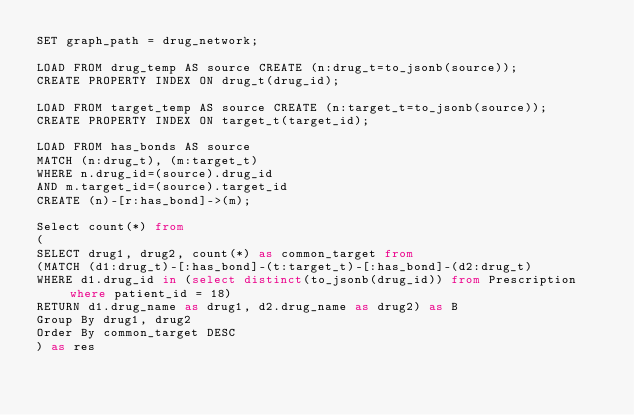Convert code to text. <code><loc_0><loc_0><loc_500><loc_500><_SQL_>SET graph_path = drug_network;

LOAD FROM drug_temp AS source CREATE (n:drug_t=to_jsonb(source));
CREATE PROPERTY INDEX ON drug_t(drug_id);

LOAD FROM target_temp AS source CREATE (n:target_t=to_jsonb(source));
CREATE PROPERTY INDEX ON target_t(target_id);

LOAD FROM has_bonds AS source
MATCH (n:drug_t), (m:target_t)
WHERE n.drug_id=(source).drug_id
AND m.target_id=(source).target_id
CREATE (n)-[r:has_bond]->(m);

Select count(*) from
(
SELECT drug1, drug2, count(*) as common_target from
(MATCH (d1:drug_t)-[:has_bond]-(t:target_t)-[:has_bond]-(d2:drug_t)
WHERE d1.drug_id in (select distinct(to_jsonb(drug_id)) from Prescription where patient_id = 18)
RETURN d1.drug_name as drug1, d2.drug_name as drug2) as B
Group By drug1, drug2
Order By common_target DESC
) as res
</code> 